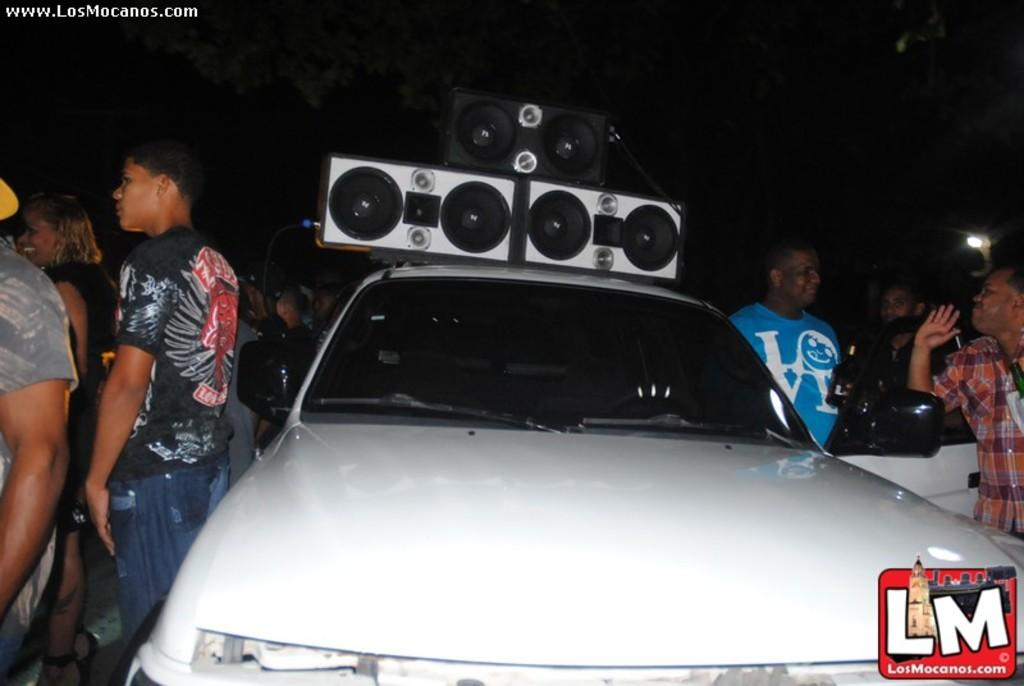What type of vehicle is in the image? There is a white car in the image. What can be seen at the top of the image? There are speakers at the top of the image. How many people are visible in the image? There are many people standing on the left and right sides of the image. What is the color of the background in the image? The background of the image is dark. Where is the desk located in the image? There is no desk present in the image. What thoughts are the people in the image having? We cannot determine the thoughts of the people in the image based on the visual information provided. 